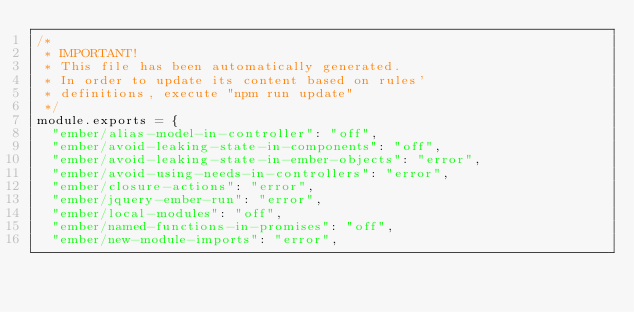Convert code to text. <code><loc_0><loc_0><loc_500><loc_500><_JavaScript_>/*
 * IMPORTANT!
 * This file has been automatically generated.
 * In order to update its content based on rules'
 * definitions, execute "npm run update"
 */
module.exports = {
  "ember/alias-model-in-controller": "off",
  "ember/avoid-leaking-state-in-components": "off",
  "ember/avoid-leaking-state-in-ember-objects": "error",
  "ember/avoid-using-needs-in-controllers": "error",
  "ember/closure-actions": "error",
  "ember/jquery-ember-run": "error",
  "ember/local-modules": "off",
  "ember/named-functions-in-promises": "off",
  "ember/new-module-imports": "error",</code> 